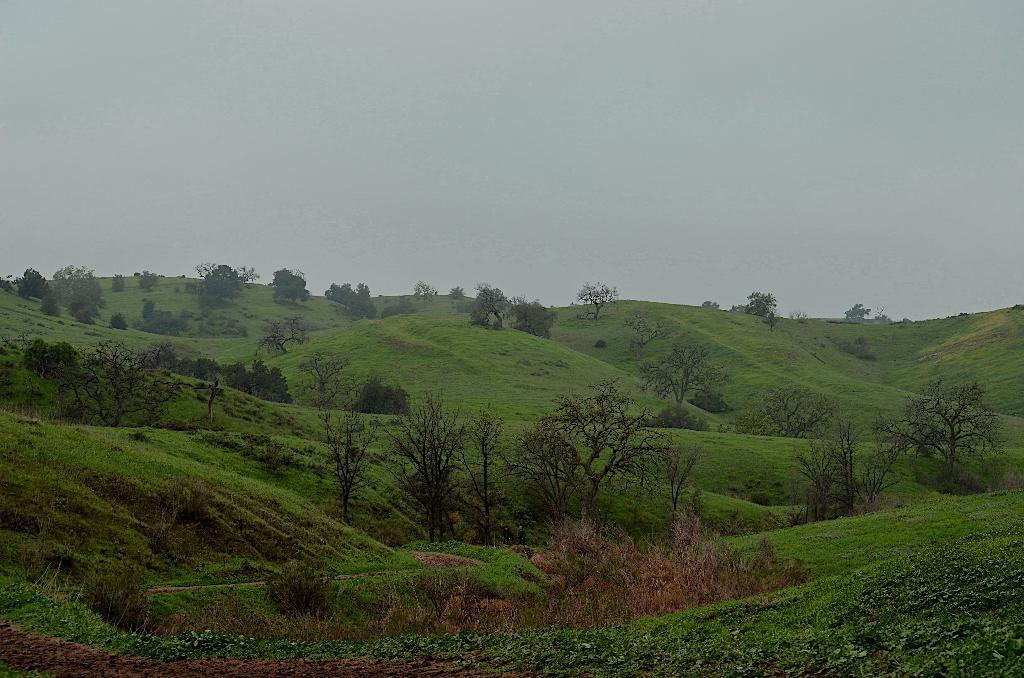What type of vegetation can be seen in the image? There is a group of trees in the image. What geographical feature is present in the image? There is a hill in the image. What part of the natural environment is visible in the image? The sky is visible in the image. What type of cake can be seen on the hill in the image? There is no cake present in the image; it features a group of trees, a hill, and the sky. How many mice are visible on the hill in the image? There are no mice present in the image; it features a group of trees, a hill, and the sky. 